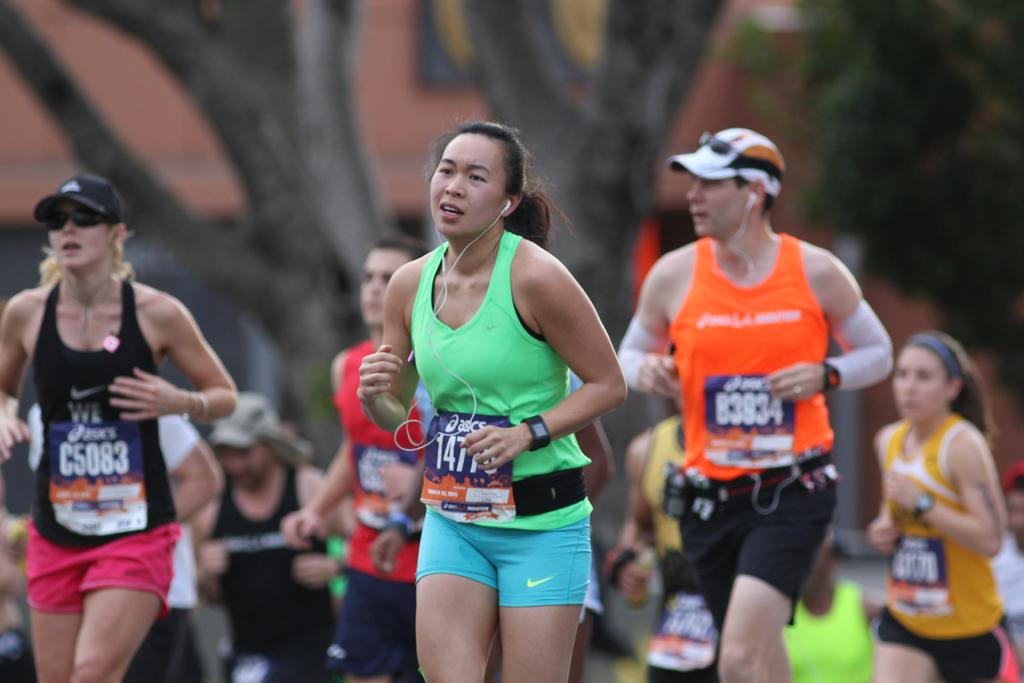<image>
Offer a succinct explanation of the picture presented. Many runners in a marathon race wearing Asics number bibs 